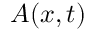Convert formula to latex. <formula><loc_0><loc_0><loc_500><loc_500>A ( x , t )</formula> 